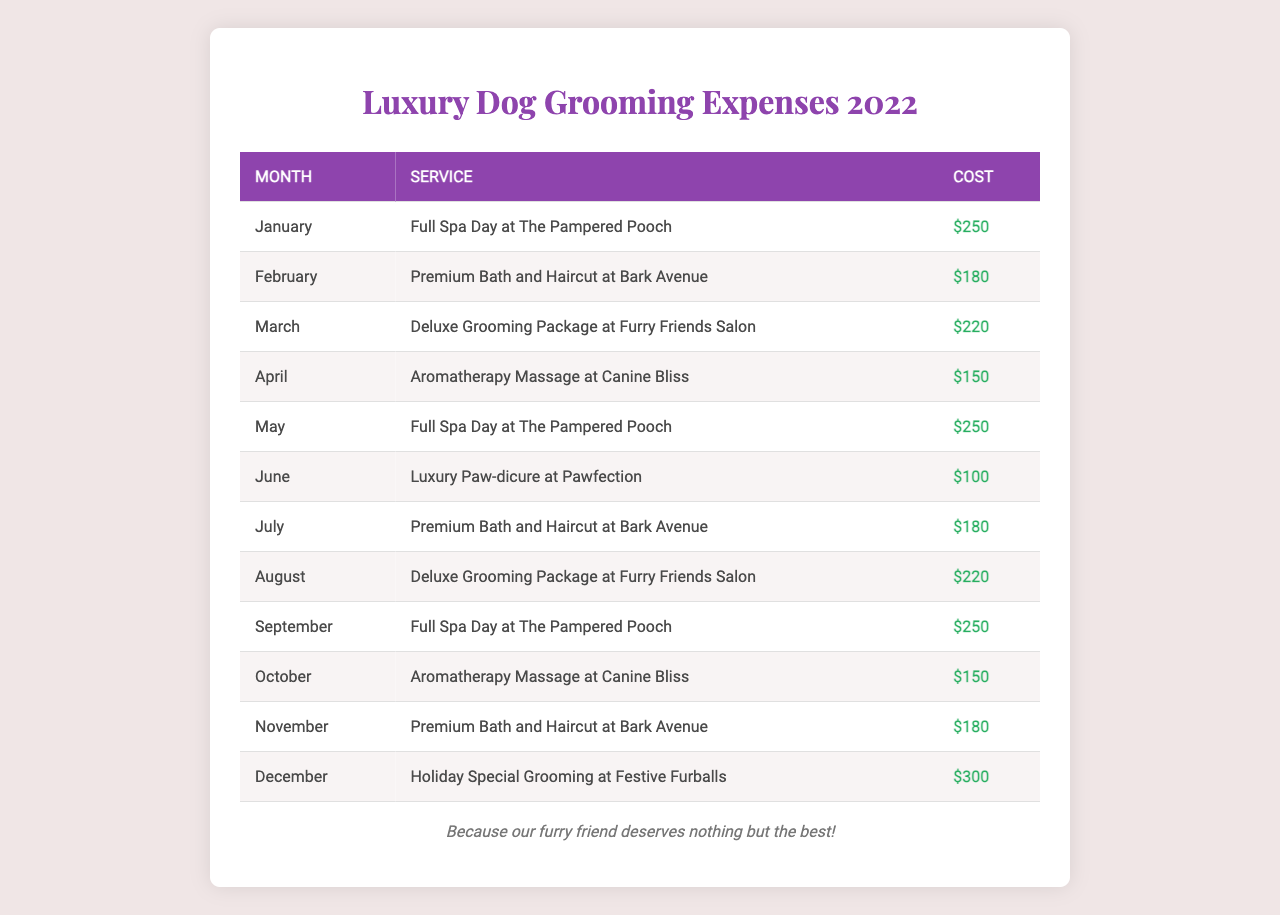What was the most expensive dog grooming service in December? The table shows that in December, the "Holiday Special Grooming at Festive Furballs" cost $300, which is the highest cost listed for that month.
Answer: $300 Which month had the lowest grooming cost? By reviewing the table, June shows the lowest cost with a "Luxury Paw-dicure at Pawfection" priced at $100.
Answer: $100 How much was spent on grooming services from January to March combined? Adding the costs for January ($250), February ($180), and March ($220) gives a total of $250 + $180 + $220 = $650.
Answer: $650 Is there a month where both the service and cost were the same as another month? Upon checking the data, no month shares both the same service and cost. Each entry is unique in terms of service provided and amount charged.
Answer: No What is the average cost of dog grooming services for the year? To find the average, sum all costs ($250 + $180 + $220 + $150 + $250 + $100 + $180 + $220 + $250 + $150 + $180 + $300 = $2,580) and divide by the number of months (12), resulting in an average of $2,580 / 12 = $215.
Answer: $215 Which service was offered the most throughout the year? The "Full Spa Day at The Pampered Pooch" appears three times in January, May, and September, which is more frequent than any other service in the table.
Answer: Full Spa Day at The Pampered Pooch Was there any month without a bath or grooming service? Reviewing all entries shows that every month involves a grooming service including baths; thus, there is no month without such a service.
Answer: No What was the total amount spent on grooming services between July and December? Adding the costs for each relevant month gives: July ($180), August ($220), September ($250), October ($150), November ($180), and December ($300). Summing those costs, we have $180 + $220 + $250 + $150 + $180 + $300 = $1,280.
Answer: $1,280 Which month had services that cost over $200? In the table, January ($250), March ($220), May ($250), September ($250), August ($220), and December ($300) all have services costing more than $200.
Answer: January, March, May, September, August, December What is the difference between the highest and lowest expenses in the year? The highest expense is $300 in December, while the lowest is $100 in June. The difference is calculated as $300 - $100 = $200.
Answer: $200 